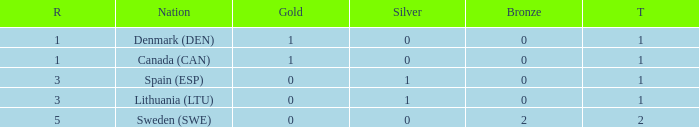What is the rank when there was less than 1 gold, 0 bronze, and more than 1 total? None. 